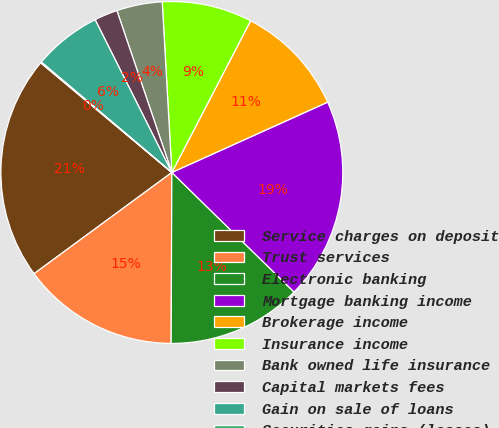<chart> <loc_0><loc_0><loc_500><loc_500><pie_chart><fcel>Service charges on deposit<fcel>Trust services<fcel>Electronic banking<fcel>Mortgage banking income<fcel>Brokerage income<fcel>Insurance income<fcel>Bank owned life insurance<fcel>Capital markets fees<fcel>Gain on sale of loans<fcel>Securities gains (losses)<nl><fcel>21.17%<fcel>14.85%<fcel>12.74%<fcel>19.07%<fcel>10.63%<fcel>8.52%<fcel>4.31%<fcel>2.2%<fcel>6.42%<fcel>0.09%<nl></chart> 